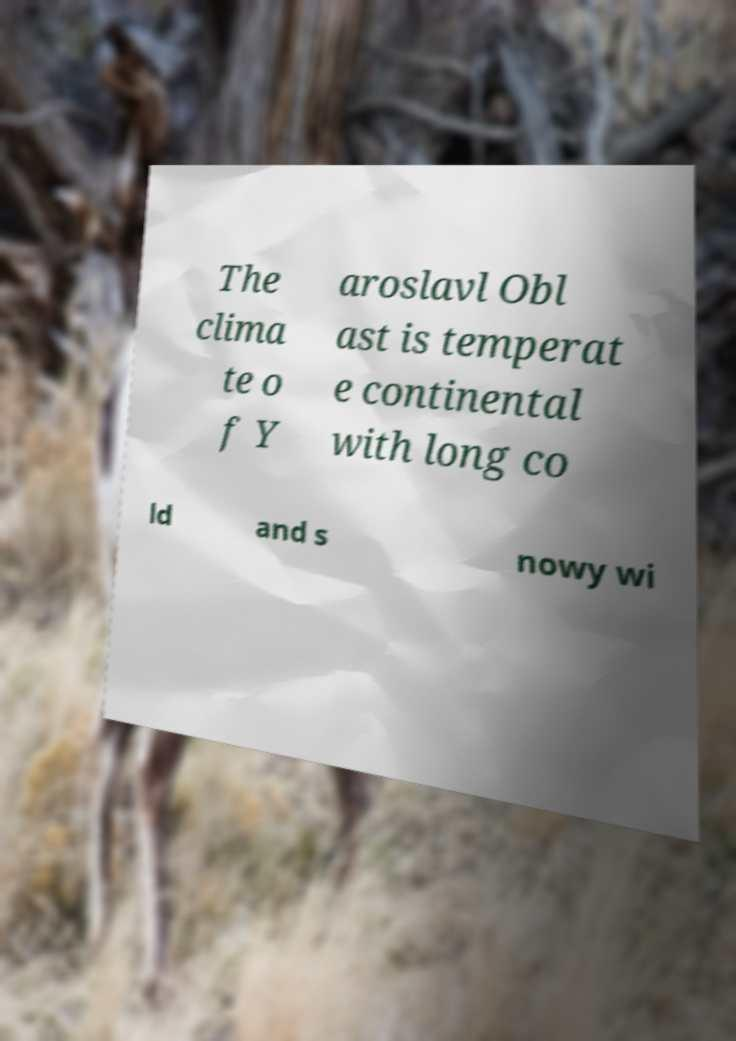Please identify and transcribe the text found in this image. The clima te o f Y aroslavl Obl ast is temperat e continental with long co ld and s nowy wi 